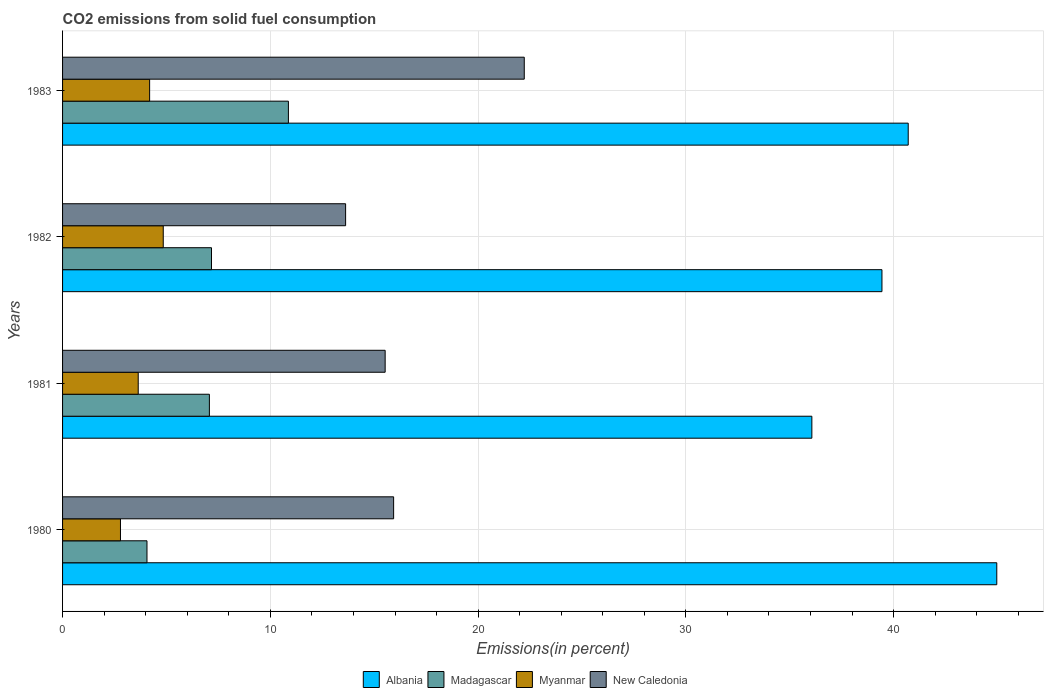How many different coloured bars are there?
Ensure brevity in your answer.  4. Are the number of bars on each tick of the Y-axis equal?
Make the answer very short. Yes. How many bars are there on the 3rd tick from the top?
Keep it short and to the point. 4. In how many cases, is the number of bars for a given year not equal to the number of legend labels?
Your response must be concise. 0. What is the total CO2 emitted in New Caledonia in 1983?
Your answer should be compact. 22.22. Across all years, what is the maximum total CO2 emitted in Madagascar?
Ensure brevity in your answer.  10.87. Across all years, what is the minimum total CO2 emitted in Myanmar?
Your response must be concise. 2.79. In which year was the total CO2 emitted in Albania maximum?
Your answer should be compact. 1980. In which year was the total CO2 emitted in Madagascar minimum?
Your answer should be compact. 1980. What is the total total CO2 emitted in Albania in the graph?
Give a very brief answer. 161.17. What is the difference between the total CO2 emitted in Myanmar in 1980 and that in 1983?
Provide a short and direct response. -1.4. What is the difference between the total CO2 emitted in New Caledonia in 1981 and the total CO2 emitted in Myanmar in 1980?
Your answer should be compact. 12.74. What is the average total CO2 emitted in New Caledonia per year?
Ensure brevity in your answer.  16.83. In the year 1983, what is the difference between the total CO2 emitted in Madagascar and total CO2 emitted in Albania?
Offer a very short reply. -29.83. What is the ratio of the total CO2 emitted in New Caledonia in 1980 to that in 1983?
Give a very brief answer. 0.72. Is the difference between the total CO2 emitted in Madagascar in 1981 and 1982 greater than the difference between the total CO2 emitted in Albania in 1981 and 1982?
Provide a succinct answer. Yes. What is the difference between the highest and the second highest total CO2 emitted in Myanmar?
Offer a very short reply. 0.66. What is the difference between the highest and the lowest total CO2 emitted in New Caledonia?
Provide a short and direct response. 8.6. What does the 3rd bar from the top in 1983 represents?
Make the answer very short. Madagascar. What does the 2nd bar from the bottom in 1981 represents?
Provide a succinct answer. Madagascar. How many bars are there?
Provide a succinct answer. 16. What is the difference between two consecutive major ticks on the X-axis?
Provide a short and direct response. 10. Are the values on the major ticks of X-axis written in scientific E-notation?
Ensure brevity in your answer.  No. Does the graph contain any zero values?
Give a very brief answer. No. Where does the legend appear in the graph?
Your answer should be very brief. Bottom center. What is the title of the graph?
Provide a short and direct response. CO2 emissions from solid fuel consumption. Does "Paraguay" appear as one of the legend labels in the graph?
Provide a short and direct response. No. What is the label or title of the X-axis?
Keep it short and to the point. Emissions(in percent). What is the label or title of the Y-axis?
Offer a very short reply. Years. What is the Emissions(in percent) in Albania in 1980?
Offer a very short reply. 44.96. What is the Emissions(in percent) in Madagascar in 1980?
Offer a very short reply. 4.06. What is the Emissions(in percent) of Myanmar in 1980?
Provide a succinct answer. 2.79. What is the Emissions(in percent) in New Caledonia in 1980?
Provide a succinct answer. 15.93. What is the Emissions(in percent) in Albania in 1981?
Provide a succinct answer. 36.06. What is the Emissions(in percent) in Madagascar in 1981?
Offer a terse response. 7.07. What is the Emissions(in percent) of Myanmar in 1981?
Ensure brevity in your answer.  3.64. What is the Emissions(in percent) of New Caledonia in 1981?
Offer a terse response. 15.53. What is the Emissions(in percent) of Albania in 1982?
Keep it short and to the point. 39.44. What is the Emissions(in percent) of Madagascar in 1982?
Keep it short and to the point. 7.17. What is the Emissions(in percent) in Myanmar in 1982?
Offer a very short reply. 4.85. What is the Emissions(in percent) in New Caledonia in 1982?
Provide a short and direct response. 13.62. What is the Emissions(in percent) in Albania in 1983?
Offer a terse response. 40.7. What is the Emissions(in percent) of Madagascar in 1983?
Provide a succinct answer. 10.87. What is the Emissions(in percent) in Myanmar in 1983?
Make the answer very short. 4.19. What is the Emissions(in percent) of New Caledonia in 1983?
Offer a very short reply. 22.22. Across all years, what is the maximum Emissions(in percent) in Albania?
Your answer should be very brief. 44.96. Across all years, what is the maximum Emissions(in percent) of Madagascar?
Give a very brief answer. 10.87. Across all years, what is the maximum Emissions(in percent) of Myanmar?
Make the answer very short. 4.85. Across all years, what is the maximum Emissions(in percent) of New Caledonia?
Provide a succinct answer. 22.22. Across all years, what is the minimum Emissions(in percent) in Albania?
Offer a terse response. 36.06. Across all years, what is the minimum Emissions(in percent) of Madagascar?
Keep it short and to the point. 4.06. Across all years, what is the minimum Emissions(in percent) in Myanmar?
Keep it short and to the point. 2.79. Across all years, what is the minimum Emissions(in percent) of New Caledonia?
Offer a very short reply. 13.62. What is the total Emissions(in percent) in Albania in the graph?
Your response must be concise. 161.17. What is the total Emissions(in percent) of Madagascar in the graph?
Provide a succinct answer. 29.17. What is the total Emissions(in percent) of Myanmar in the graph?
Offer a very short reply. 15.46. What is the total Emissions(in percent) of New Caledonia in the graph?
Provide a short and direct response. 67.31. What is the difference between the Emissions(in percent) of Albania in 1980 and that in 1981?
Provide a succinct answer. 8.9. What is the difference between the Emissions(in percent) in Madagascar in 1980 and that in 1981?
Give a very brief answer. -3. What is the difference between the Emissions(in percent) in Myanmar in 1980 and that in 1981?
Give a very brief answer. -0.85. What is the difference between the Emissions(in percent) in New Caledonia in 1980 and that in 1981?
Provide a short and direct response. 0.41. What is the difference between the Emissions(in percent) in Albania in 1980 and that in 1982?
Offer a very short reply. 5.53. What is the difference between the Emissions(in percent) of Madagascar in 1980 and that in 1982?
Offer a terse response. -3.11. What is the difference between the Emissions(in percent) in Myanmar in 1980 and that in 1982?
Provide a short and direct response. -2.06. What is the difference between the Emissions(in percent) of New Caledonia in 1980 and that in 1982?
Provide a short and direct response. 2.31. What is the difference between the Emissions(in percent) of Albania in 1980 and that in 1983?
Your answer should be very brief. 4.26. What is the difference between the Emissions(in percent) in Madagascar in 1980 and that in 1983?
Make the answer very short. -6.81. What is the difference between the Emissions(in percent) of Myanmar in 1980 and that in 1983?
Your answer should be very brief. -1.4. What is the difference between the Emissions(in percent) in New Caledonia in 1980 and that in 1983?
Ensure brevity in your answer.  -6.29. What is the difference between the Emissions(in percent) in Albania in 1981 and that in 1982?
Provide a short and direct response. -3.37. What is the difference between the Emissions(in percent) in Madagascar in 1981 and that in 1982?
Your response must be concise. -0.1. What is the difference between the Emissions(in percent) in Myanmar in 1981 and that in 1982?
Your answer should be very brief. -1.21. What is the difference between the Emissions(in percent) in New Caledonia in 1981 and that in 1982?
Your answer should be very brief. 1.9. What is the difference between the Emissions(in percent) in Albania in 1981 and that in 1983?
Your answer should be very brief. -4.64. What is the difference between the Emissions(in percent) of Madagascar in 1981 and that in 1983?
Ensure brevity in your answer.  -3.8. What is the difference between the Emissions(in percent) in Myanmar in 1981 and that in 1983?
Your answer should be compact. -0.55. What is the difference between the Emissions(in percent) in New Caledonia in 1981 and that in 1983?
Your response must be concise. -6.7. What is the difference between the Emissions(in percent) of Albania in 1982 and that in 1983?
Your answer should be very brief. -1.26. What is the difference between the Emissions(in percent) of Madagascar in 1982 and that in 1983?
Offer a terse response. -3.7. What is the difference between the Emissions(in percent) in Myanmar in 1982 and that in 1983?
Your answer should be compact. 0.66. What is the difference between the Emissions(in percent) in New Caledonia in 1982 and that in 1983?
Make the answer very short. -8.6. What is the difference between the Emissions(in percent) in Albania in 1980 and the Emissions(in percent) in Madagascar in 1981?
Your answer should be compact. 37.9. What is the difference between the Emissions(in percent) in Albania in 1980 and the Emissions(in percent) in Myanmar in 1981?
Give a very brief answer. 41.32. What is the difference between the Emissions(in percent) in Albania in 1980 and the Emissions(in percent) in New Caledonia in 1981?
Your answer should be compact. 29.44. What is the difference between the Emissions(in percent) of Madagascar in 1980 and the Emissions(in percent) of Myanmar in 1981?
Make the answer very short. 0.42. What is the difference between the Emissions(in percent) of Madagascar in 1980 and the Emissions(in percent) of New Caledonia in 1981?
Ensure brevity in your answer.  -11.46. What is the difference between the Emissions(in percent) of Myanmar in 1980 and the Emissions(in percent) of New Caledonia in 1981?
Offer a terse response. -12.74. What is the difference between the Emissions(in percent) in Albania in 1980 and the Emissions(in percent) in Madagascar in 1982?
Provide a succinct answer. 37.8. What is the difference between the Emissions(in percent) of Albania in 1980 and the Emissions(in percent) of Myanmar in 1982?
Your answer should be compact. 40.12. What is the difference between the Emissions(in percent) of Albania in 1980 and the Emissions(in percent) of New Caledonia in 1982?
Your response must be concise. 31.34. What is the difference between the Emissions(in percent) in Madagascar in 1980 and the Emissions(in percent) in Myanmar in 1982?
Offer a very short reply. -0.78. What is the difference between the Emissions(in percent) in Madagascar in 1980 and the Emissions(in percent) in New Caledonia in 1982?
Your response must be concise. -9.56. What is the difference between the Emissions(in percent) of Myanmar in 1980 and the Emissions(in percent) of New Caledonia in 1982?
Ensure brevity in your answer.  -10.84. What is the difference between the Emissions(in percent) in Albania in 1980 and the Emissions(in percent) in Madagascar in 1983?
Make the answer very short. 34.09. What is the difference between the Emissions(in percent) in Albania in 1980 and the Emissions(in percent) in Myanmar in 1983?
Offer a very short reply. 40.77. What is the difference between the Emissions(in percent) in Albania in 1980 and the Emissions(in percent) in New Caledonia in 1983?
Give a very brief answer. 22.74. What is the difference between the Emissions(in percent) of Madagascar in 1980 and the Emissions(in percent) of Myanmar in 1983?
Provide a succinct answer. -0.13. What is the difference between the Emissions(in percent) in Madagascar in 1980 and the Emissions(in percent) in New Caledonia in 1983?
Offer a terse response. -18.16. What is the difference between the Emissions(in percent) of Myanmar in 1980 and the Emissions(in percent) of New Caledonia in 1983?
Offer a terse response. -19.44. What is the difference between the Emissions(in percent) in Albania in 1981 and the Emissions(in percent) in Madagascar in 1982?
Provide a succinct answer. 28.9. What is the difference between the Emissions(in percent) of Albania in 1981 and the Emissions(in percent) of Myanmar in 1982?
Provide a succinct answer. 31.22. What is the difference between the Emissions(in percent) of Albania in 1981 and the Emissions(in percent) of New Caledonia in 1982?
Provide a short and direct response. 22.44. What is the difference between the Emissions(in percent) of Madagascar in 1981 and the Emissions(in percent) of Myanmar in 1982?
Keep it short and to the point. 2.22. What is the difference between the Emissions(in percent) of Madagascar in 1981 and the Emissions(in percent) of New Caledonia in 1982?
Provide a short and direct response. -6.56. What is the difference between the Emissions(in percent) in Myanmar in 1981 and the Emissions(in percent) in New Caledonia in 1982?
Give a very brief answer. -9.98. What is the difference between the Emissions(in percent) in Albania in 1981 and the Emissions(in percent) in Madagascar in 1983?
Keep it short and to the point. 25.19. What is the difference between the Emissions(in percent) of Albania in 1981 and the Emissions(in percent) of Myanmar in 1983?
Your answer should be very brief. 31.87. What is the difference between the Emissions(in percent) of Albania in 1981 and the Emissions(in percent) of New Caledonia in 1983?
Offer a very short reply. 13.84. What is the difference between the Emissions(in percent) of Madagascar in 1981 and the Emissions(in percent) of Myanmar in 1983?
Offer a very short reply. 2.88. What is the difference between the Emissions(in percent) of Madagascar in 1981 and the Emissions(in percent) of New Caledonia in 1983?
Offer a terse response. -15.16. What is the difference between the Emissions(in percent) in Myanmar in 1981 and the Emissions(in percent) in New Caledonia in 1983?
Provide a short and direct response. -18.58. What is the difference between the Emissions(in percent) of Albania in 1982 and the Emissions(in percent) of Madagascar in 1983?
Offer a terse response. 28.57. What is the difference between the Emissions(in percent) of Albania in 1982 and the Emissions(in percent) of Myanmar in 1983?
Offer a very short reply. 35.25. What is the difference between the Emissions(in percent) in Albania in 1982 and the Emissions(in percent) in New Caledonia in 1983?
Make the answer very short. 17.22. What is the difference between the Emissions(in percent) in Madagascar in 1982 and the Emissions(in percent) in Myanmar in 1983?
Provide a succinct answer. 2.98. What is the difference between the Emissions(in percent) in Madagascar in 1982 and the Emissions(in percent) in New Caledonia in 1983?
Keep it short and to the point. -15.05. What is the difference between the Emissions(in percent) of Myanmar in 1982 and the Emissions(in percent) of New Caledonia in 1983?
Offer a terse response. -17.38. What is the average Emissions(in percent) in Albania per year?
Your answer should be compact. 40.29. What is the average Emissions(in percent) in Madagascar per year?
Your response must be concise. 7.29. What is the average Emissions(in percent) of Myanmar per year?
Ensure brevity in your answer.  3.87. What is the average Emissions(in percent) in New Caledonia per year?
Your answer should be compact. 16.83. In the year 1980, what is the difference between the Emissions(in percent) of Albania and Emissions(in percent) of Madagascar?
Offer a terse response. 40.9. In the year 1980, what is the difference between the Emissions(in percent) in Albania and Emissions(in percent) in Myanmar?
Your answer should be compact. 42.18. In the year 1980, what is the difference between the Emissions(in percent) of Albania and Emissions(in percent) of New Caledonia?
Your response must be concise. 29.03. In the year 1980, what is the difference between the Emissions(in percent) of Madagascar and Emissions(in percent) of Myanmar?
Make the answer very short. 1.28. In the year 1980, what is the difference between the Emissions(in percent) in Madagascar and Emissions(in percent) in New Caledonia?
Your response must be concise. -11.87. In the year 1980, what is the difference between the Emissions(in percent) of Myanmar and Emissions(in percent) of New Caledonia?
Provide a short and direct response. -13.15. In the year 1981, what is the difference between the Emissions(in percent) of Albania and Emissions(in percent) of Madagascar?
Offer a terse response. 29. In the year 1981, what is the difference between the Emissions(in percent) of Albania and Emissions(in percent) of Myanmar?
Offer a very short reply. 32.42. In the year 1981, what is the difference between the Emissions(in percent) of Albania and Emissions(in percent) of New Caledonia?
Give a very brief answer. 20.54. In the year 1981, what is the difference between the Emissions(in percent) of Madagascar and Emissions(in percent) of Myanmar?
Offer a terse response. 3.43. In the year 1981, what is the difference between the Emissions(in percent) in Madagascar and Emissions(in percent) in New Caledonia?
Provide a short and direct response. -8.46. In the year 1981, what is the difference between the Emissions(in percent) in Myanmar and Emissions(in percent) in New Caledonia?
Make the answer very short. -11.89. In the year 1982, what is the difference between the Emissions(in percent) of Albania and Emissions(in percent) of Madagascar?
Ensure brevity in your answer.  32.27. In the year 1982, what is the difference between the Emissions(in percent) of Albania and Emissions(in percent) of Myanmar?
Provide a succinct answer. 34.59. In the year 1982, what is the difference between the Emissions(in percent) of Albania and Emissions(in percent) of New Caledonia?
Provide a succinct answer. 25.81. In the year 1982, what is the difference between the Emissions(in percent) in Madagascar and Emissions(in percent) in Myanmar?
Keep it short and to the point. 2.32. In the year 1982, what is the difference between the Emissions(in percent) in Madagascar and Emissions(in percent) in New Caledonia?
Make the answer very short. -6.45. In the year 1982, what is the difference between the Emissions(in percent) in Myanmar and Emissions(in percent) in New Caledonia?
Keep it short and to the point. -8.78. In the year 1983, what is the difference between the Emissions(in percent) in Albania and Emissions(in percent) in Madagascar?
Your answer should be very brief. 29.83. In the year 1983, what is the difference between the Emissions(in percent) in Albania and Emissions(in percent) in Myanmar?
Your response must be concise. 36.51. In the year 1983, what is the difference between the Emissions(in percent) of Albania and Emissions(in percent) of New Caledonia?
Offer a very short reply. 18.48. In the year 1983, what is the difference between the Emissions(in percent) of Madagascar and Emissions(in percent) of Myanmar?
Provide a short and direct response. 6.68. In the year 1983, what is the difference between the Emissions(in percent) of Madagascar and Emissions(in percent) of New Caledonia?
Make the answer very short. -11.35. In the year 1983, what is the difference between the Emissions(in percent) in Myanmar and Emissions(in percent) in New Caledonia?
Your answer should be very brief. -18.03. What is the ratio of the Emissions(in percent) in Albania in 1980 to that in 1981?
Ensure brevity in your answer.  1.25. What is the ratio of the Emissions(in percent) in Madagascar in 1980 to that in 1981?
Offer a very short reply. 0.57. What is the ratio of the Emissions(in percent) of Myanmar in 1980 to that in 1981?
Ensure brevity in your answer.  0.77. What is the ratio of the Emissions(in percent) in New Caledonia in 1980 to that in 1981?
Your answer should be very brief. 1.03. What is the ratio of the Emissions(in percent) in Albania in 1980 to that in 1982?
Provide a succinct answer. 1.14. What is the ratio of the Emissions(in percent) of Madagascar in 1980 to that in 1982?
Provide a succinct answer. 0.57. What is the ratio of the Emissions(in percent) in Myanmar in 1980 to that in 1982?
Keep it short and to the point. 0.58. What is the ratio of the Emissions(in percent) of New Caledonia in 1980 to that in 1982?
Your answer should be compact. 1.17. What is the ratio of the Emissions(in percent) of Albania in 1980 to that in 1983?
Make the answer very short. 1.1. What is the ratio of the Emissions(in percent) of Madagascar in 1980 to that in 1983?
Give a very brief answer. 0.37. What is the ratio of the Emissions(in percent) of Myanmar in 1980 to that in 1983?
Provide a short and direct response. 0.67. What is the ratio of the Emissions(in percent) in New Caledonia in 1980 to that in 1983?
Offer a terse response. 0.72. What is the ratio of the Emissions(in percent) in Albania in 1981 to that in 1982?
Keep it short and to the point. 0.91. What is the ratio of the Emissions(in percent) in Madagascar in 1981 to that in 1982?
Your response must be concise. 0.99. What is the ratio of the Emissions(in percent) in Myanmar in 1981 to that in 1982?
Your answer should be very brief. 0.75. What is the ratio of the Emissions(in percent) in New Caledonia in 1981 to that in 1982?
Provide a short and direct response. 1.14. What is the ratio of the Emissions(in percent) of Albania in 1981 to that in 1983?
Your answer should be compact. 0.89. What is the ratio of the Emissions(in percent) in Madagascar in 1981 to that in 1983?
Your response must be concise. 0.65. What is the ratio of the Emissions(in percent) of Myanmar in 1981 to that in 1983?
Provide a succinct answer. 0.87. What is the ratio of the Emissions(in percent) in New Caledonia in 1981 to that in 1983?
Give a very brief answer. 0.7. What is the ratio of the Emissions(in percent) of Albania in 1982 to that in 1983?
Your response must be concise. 0.97. What is the ratio of the Emissions(in percent) in Madagascar in 1982 to that in 1983?
Keep it short and to the point. 0.66. What is the ratio of the Emissions(in percent) of Myanmar in 1982 to that in 1983?
Ensure brevity in your answer.  1.16. What is the ratio of the Emissions(in percent) in New Caledonia in 1982 to that in 1983?
Provide a short and direct response. 0.61. What is the difference between the highest and the second highest Emissions(in percent) in Albania?
Keep it short and to the point. 4.26. What is the difference between the highest and the second highest Emissions(in percent) of Madagascar?
Offer a very short reply. 3.7. What is the difference between the highest and the second highest Emissions(in percent) in Myanmar?
Give a very brief answer. 0.66. What is the difference between the highest and the second highest Emissions(in percent) of New Caledonia?
Your answer should be very brief. 6.29. What is the difference between the highest and the lowest Emissions(in percent) in Albania?
Ensure brevity in your answer.  8.9. What is the difference between the highest and the lowest Emissions(in percent) in Madagascar?
Provide a succinct answer. 6.81. What is the difference between the highest and the lowest Emissions(in percent) in Myanmar?
Keep it short and to the point. 2.06. What is the difference between the highest and the lowest Emissions(in percent) of New Caledonia?
Your answer should be compact. 8.6. 